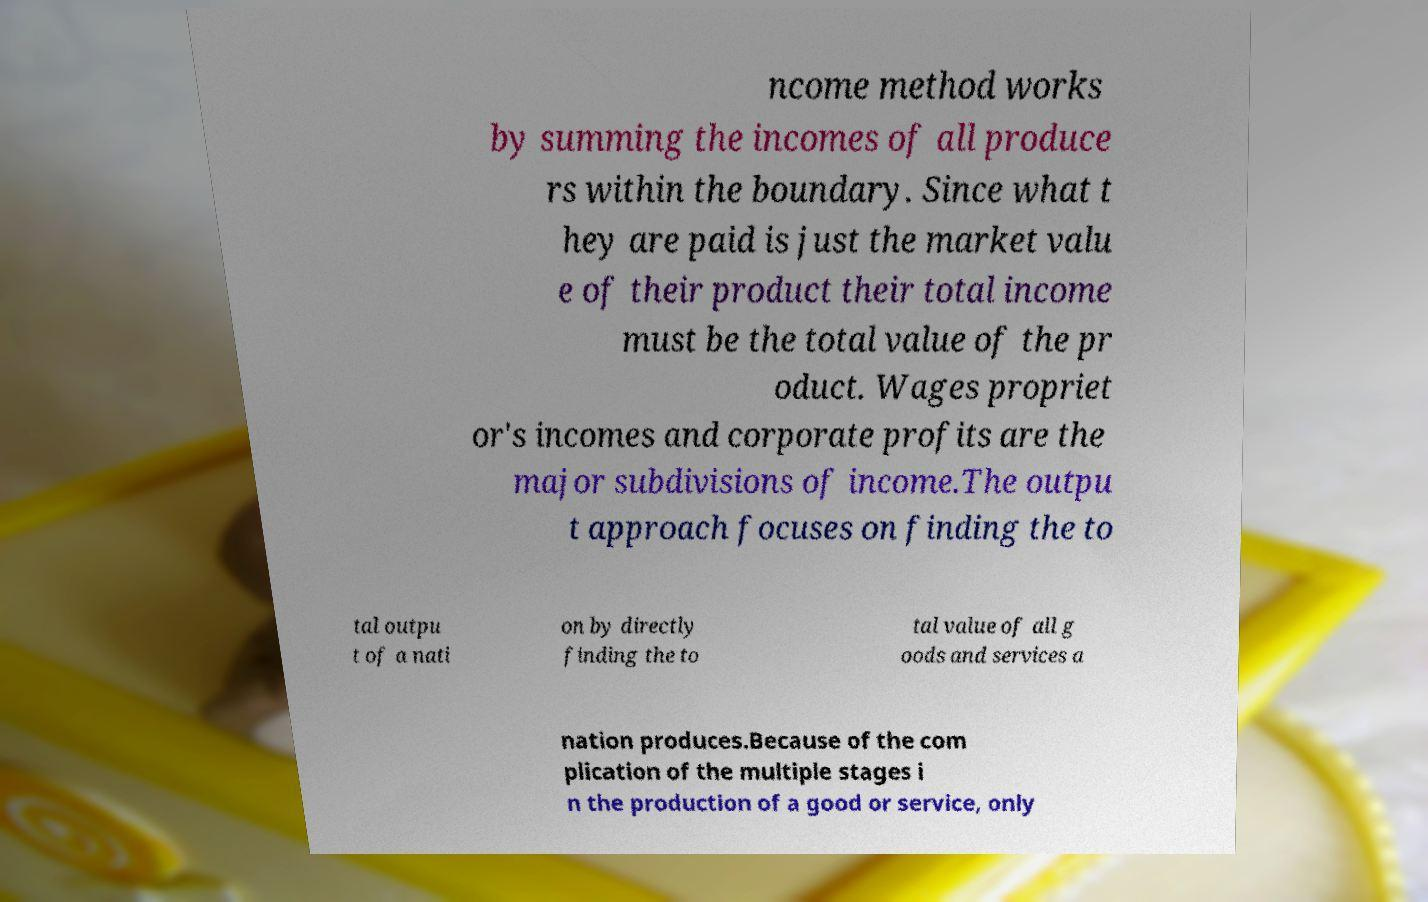I need the written content from this picture converted into text. Can you do that? ncome method works by summing the incomes of all produce rs within the boundary. Since what t hey are paid is just the market valu e of their product their total income must be the total value of the pr oduct. Wages propriet or's incomes and corporate profits are the major subdivisions of income.The outpu t approach focuses on finding the to tal outpu t of a nati on by directly finding the to tal value of all g oods and services a nation produces.Because of the com plication of the multiple stages i n the production of a good or service, only 